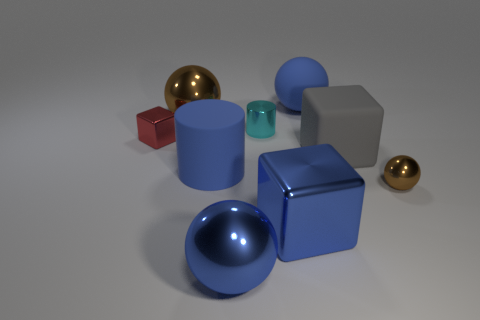What is the size of the gray matte cube?
Offer a very short reply. Large. Does the small sphere have the same color as the metal ball behind the gray block?
Keep it short and to the point. Yes. There is a metallic cube that is to the right of the brown metal object that is behind the red block; what color is it?
Make the answer very short. Blue. There is a big metallic object behind the small metal sphere; does it have the same shape as the tiny brown thing?
Provide a succinct answer. Yes. How many big shiny things are both on the left side of the cyan thing and in front of the large matte cube?
Your response must be concise. 1. What is the color of the block that is on the left side of the small cyan cylinder in front of the brown metal sphere to the left of the tiny cyan shiny cylinder?
Provide a short and direct response. Red. How many blue cubes are left of the brown object in front of the tiny cube?
Your answer should be compact. 1. How many other things are the same shape as the big gray object?
Ensure brevity in your answer.  2. What number of objects are either big spheres or large spheres that are on the right side of the blue shiny block?
Your response must be concise. 3. Is the number of tiny cyan cylinders behind the rubber cube greater than the number of tiny brown balls behind the tiny brown metallic object?
Your answer should be compact. Yes. 